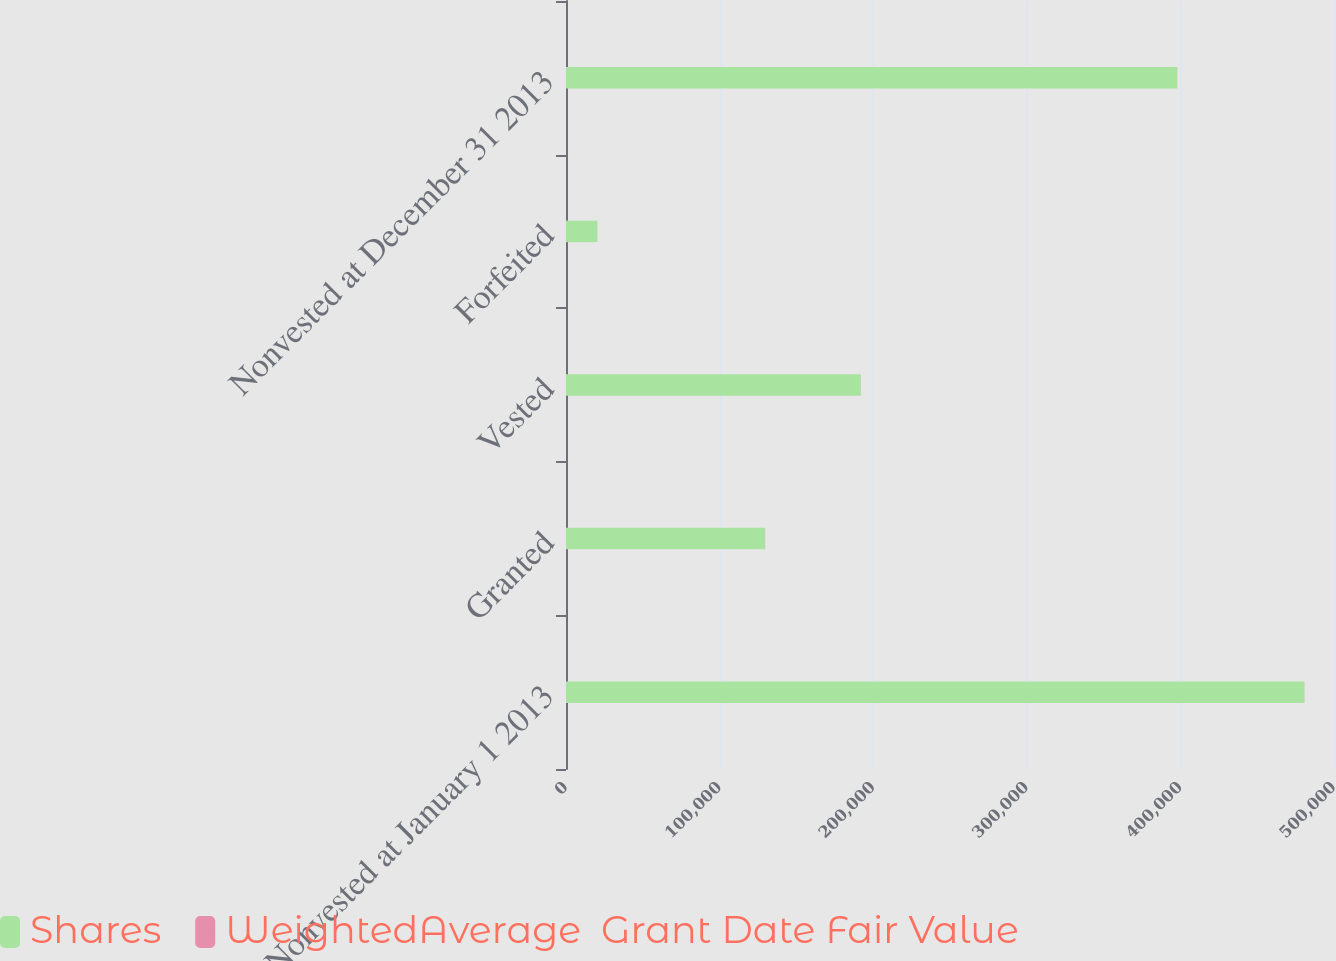Convert chart. <chart><loc_0><loc_0><loc_500><loc_500><stacked_bar_chart><ecel><fcel>Nonvested at January 1 2013<fcel>Granted<fcel>Vested<fcel>Forfeited<fcel>Nonvested at December 31 2013<nl><fcel>Shares<fcel>480753<fcel>129620<fcel>191988<fcel>20409<fcel>397976<nl><fcel>WeightedAverage  Grant Date Fair Value<fcel>43.58<fcel>55.21<fcel>40.33<fcel>45.7<fcel>47.74<nl></chart> 